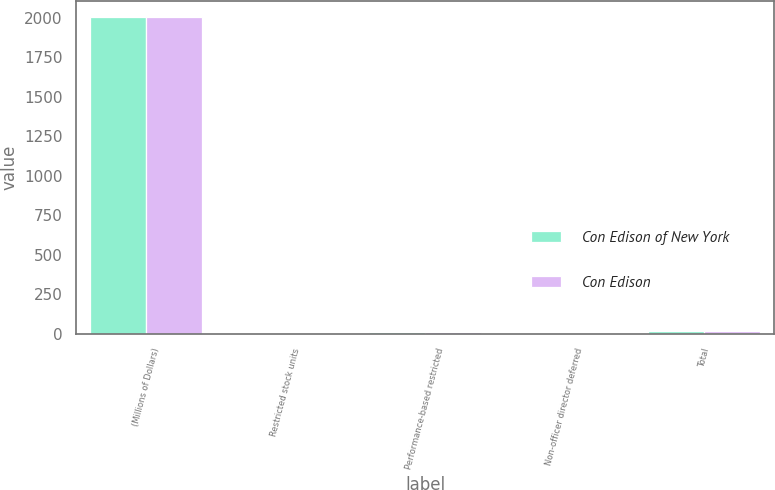Convert chart. <chart><loc_0><loc_0><loc_500><loc_500><stacked_bar_chart><ecel><fcel>(Millions of Dollars)<fcel>Restricted stock units<fcel>Performance-based restricted<fcel>Non-officer director deferred<fcel>Total<nl><fcel>Con Edison of New York<fcel>2006<fcel>1<fcel>11<fcel>1<fcel>20<nl><fcel>Con Edison<fcel>2006<fcel>1<fcel>10<fcel>1<fcel>18<nl></chart> 